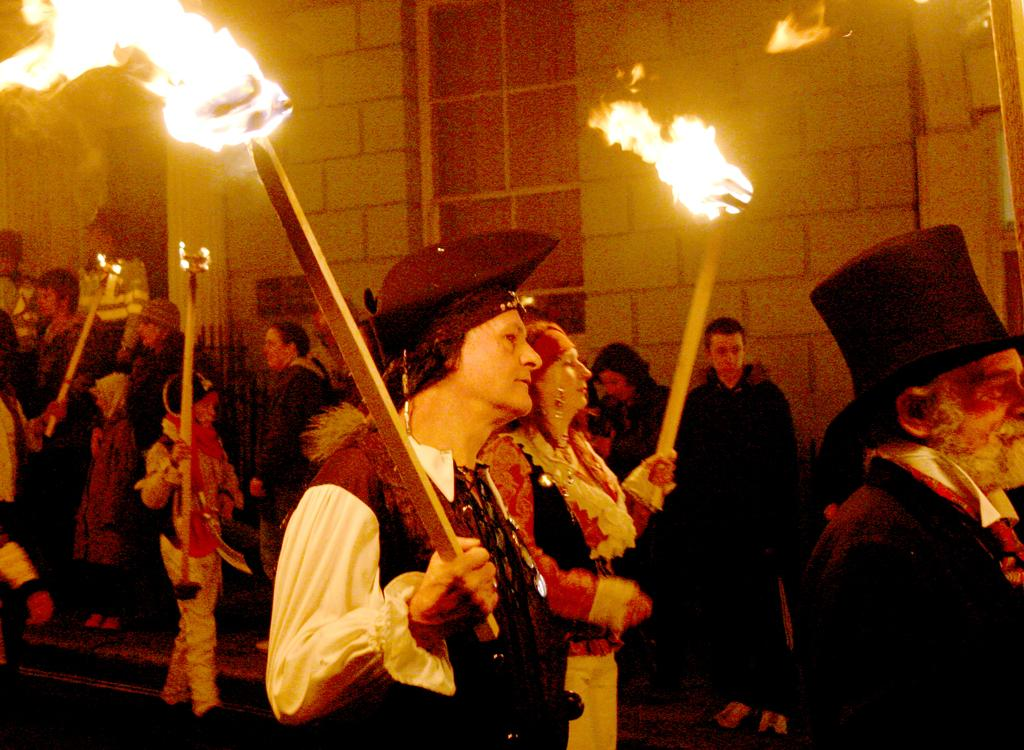What are the people in the image doing? The people in the image are standing on the ground. What are some of the people holding in their hands? Some of the people are holding fire torches in their hands. What can be seen in the background of the image? There are windows and a brick wall visible in the background of the image. Can you tell me how many clover leaves are on the stranger's hat in the image? There is no stranger or hat with clover leaves present in the image. 